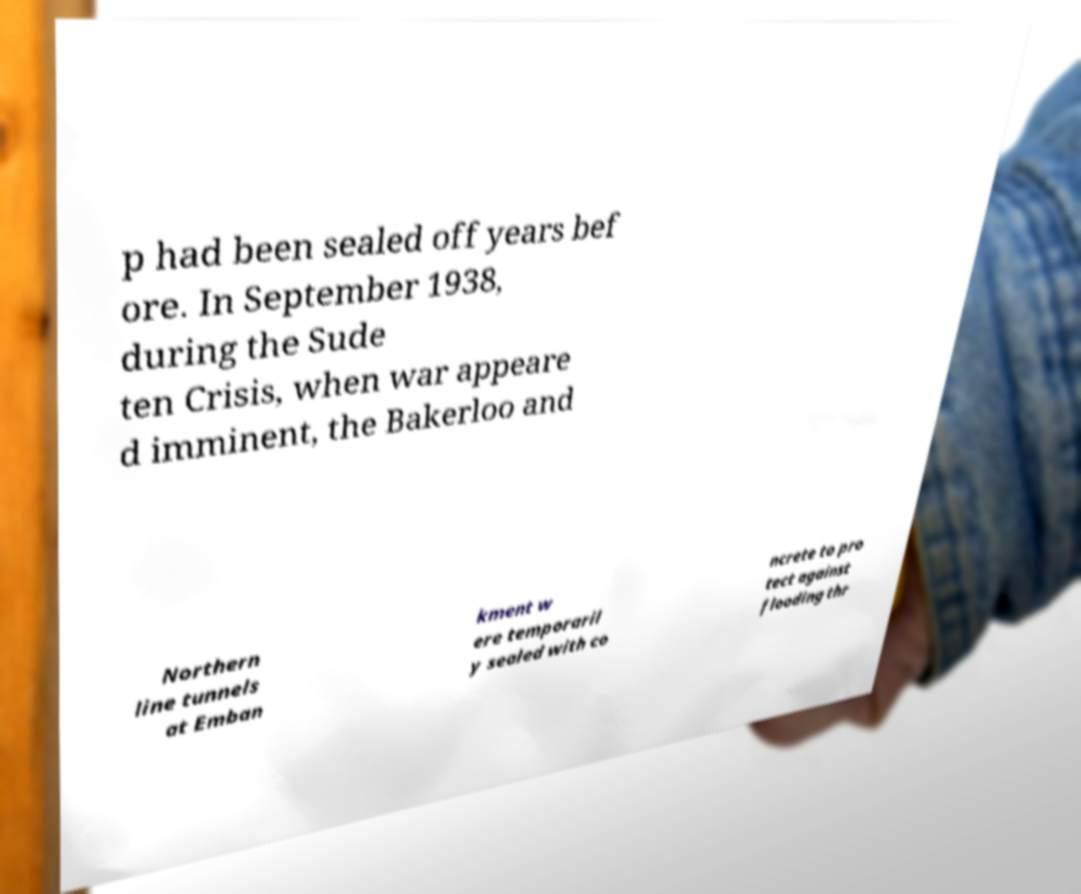Can you accurately transcribe the text from the provided image for me? p had been sealed off years bef ore. In September 1938, during the Sude ten Crisis, when war appeare d imminent, the Bakerloo and Northern line tunnels at Emban kment w ere temporaril y sealed with co ncrete to pro tect against flooding thr 